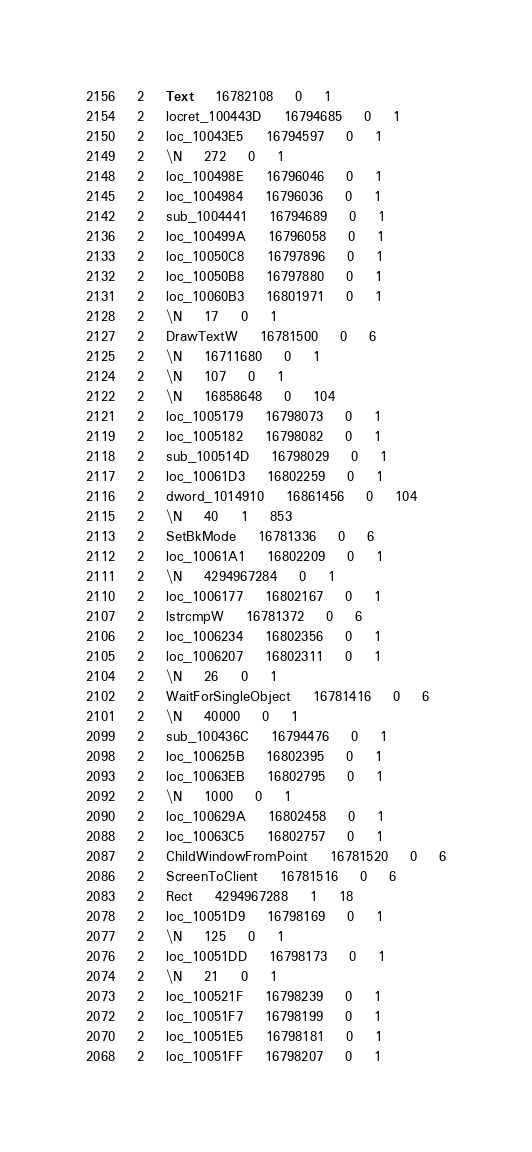Convert code to text. <code><loc_0><loc_0><loc_500><loc_500><_SQL_>2156	2	Text	16782108	0	1
2154	2	locret_100443D	16794685	0	1
2150	2	loc_10043E5	16794597	0	1
2149	2	\N	272	0	1
2148	2	loc_100498E	16796046	0	1
2145	2	loc_1004984	16796036	0	1
2142	2	sub_1004441	16794689	0	1
2136	2	loc_100499A	16796058	0	1
2133	2	loc_10050C8	16797896	0	1
2132	2	loc_10050B8	16797880	0	1
2131	2	loc_10060B3	16801971	0	1
2128	2	\N	17	0	1
2127	2	DrawTextW	16781500	0	6
2125	2	\N	16711680	0	1
2124	2	\N	107	0	1
2122	2	\N	16858648	0	104
2121	2	loc_1005179	16798073	0	1
2119	2	loc_1005182	16798082	0	1
2118	2	sub_100514D	16798029	0	1
2117	2	loc_10061D3	16802259	0	1
2116	2	dword_1014910	16861456	0	104
2115	2	\N	40	1	853
2113	2	SetBkMode	16781336	0	6
2112	2	loc_10061A1	16802209	0	1
2111	2	\N	4294967284	0	1
2110	2	loc_1006177	16802167	0	1
2107	2	lstrcmpW	16781372	0	6
2106	2	loc_1006234	16802356	0	1
2105	2	loc_1006207	16802311	0	1
2104	2	\N	26	0	1
2102	2	WaitForSingleObject	16781416	0	6
2101	2	\N	40000	0	1
2099	2	sub_100436C	16794476	0	1
2098	2	loc_100625B	16802395	0	1
2093	2	loc_10063EB	16802795	0	1
2092	2	\N	1000	0	1
2090	2	loc_100629A	16802458	0	1
2088	2	loc_10063C5	16802757	0	1
2087	2	ChildWindowFromPoint	16781520	0	6
2086	2	ScreenToClient	16781516	0	6
2083	2	Rect	4294967288	1	18
2078	2	loc_10051D9	16798169	0	1
2077	2	\N	125	0	1
2076	2	loc_10051DD	16798173	0	1
2074	2	\N	21	0	1
2073	2	loc_100521F	16798239	0	1
2072	2	loc_10051F7	16798199	0	1
2070	2	loc_10051E5	16798181	0	1
2068	2	loc_10051FF	16798207	0	1</code> 